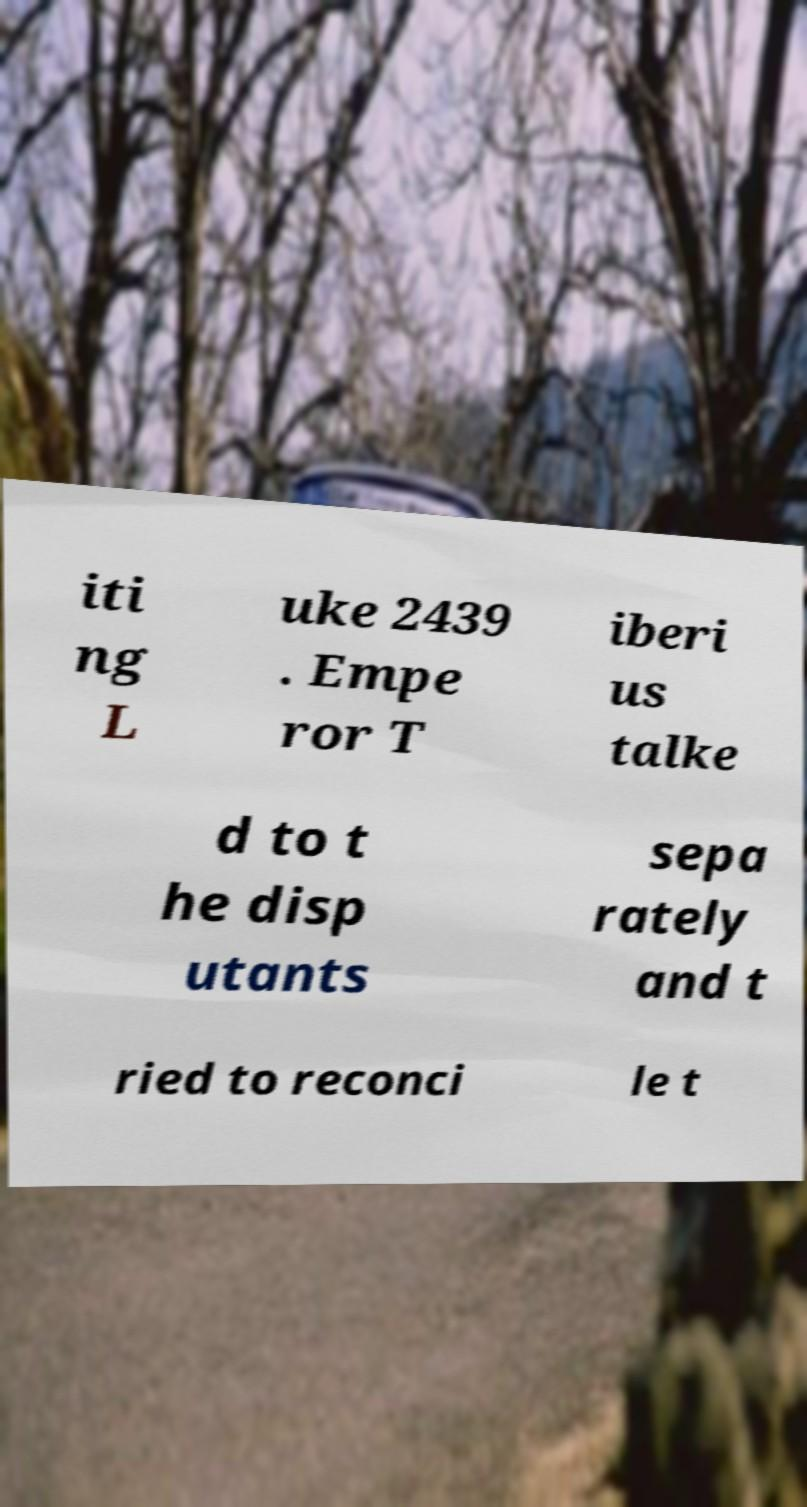Can you accurately transcribe the text from the provided image for me? iti ng L uke 2439 . Empe ror T iberi us talke d to t he disp utants sepa rately and t ried to reconci le t 